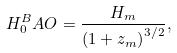Convert formula to latex. <formula><loc_0><loc_0><loc_500><loc_500>H _ { 0 } ^ { B } A O = \frac { H _ { m } } { \left ( 1 + z _ { m } \right ) ^ { 3 / 2 } } ,</formula> 